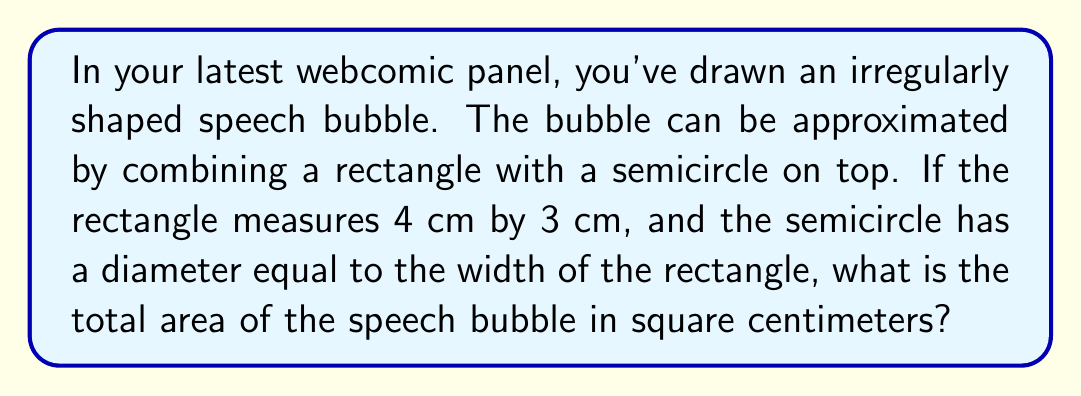Help me with this question. Let's break this down step-by-step:

1. Calculate the area of the rectangle:
   $A_{rectangle} = l \times w = 4 \text{ cm} \times 3 \text{ cm} = 12 \text{ cm}^2$

2. Calculate the area of the semicircle:
   - The diameter of the semicircle is equal to the width of the rectangle, which is 3 cm.
   - The radius is half of this: $r = 3 \text{ cm} \div 2 = 1.5 \text{ cm}$
   - Area of a full circle: $A_{circle} = \pi r^2$
   - Area of a semicircle: $A_{semicircle} = \frac{1}{2} \pi r^2$
   
   $A_{semicircle} = \frac{1}{2} \pi (1.5 \text{ cm})^2 = \frac{1}{2} \pi (2.25 \text{ cm}^2) \approx 3.53 \text{ cm}^2$

3. Sum the areas:
   $A_{total} = A_{rectangle} + A_{semicircle} = 12 \text{ cm}^2 + 3.53 \text{ cm}^2 = 15.53 \text{ cm}^2$

Therefore, the total area of the speech bubble is approximately 15.53 square centimeters.
Answer: $15.53 \text{ cm}^2$ 